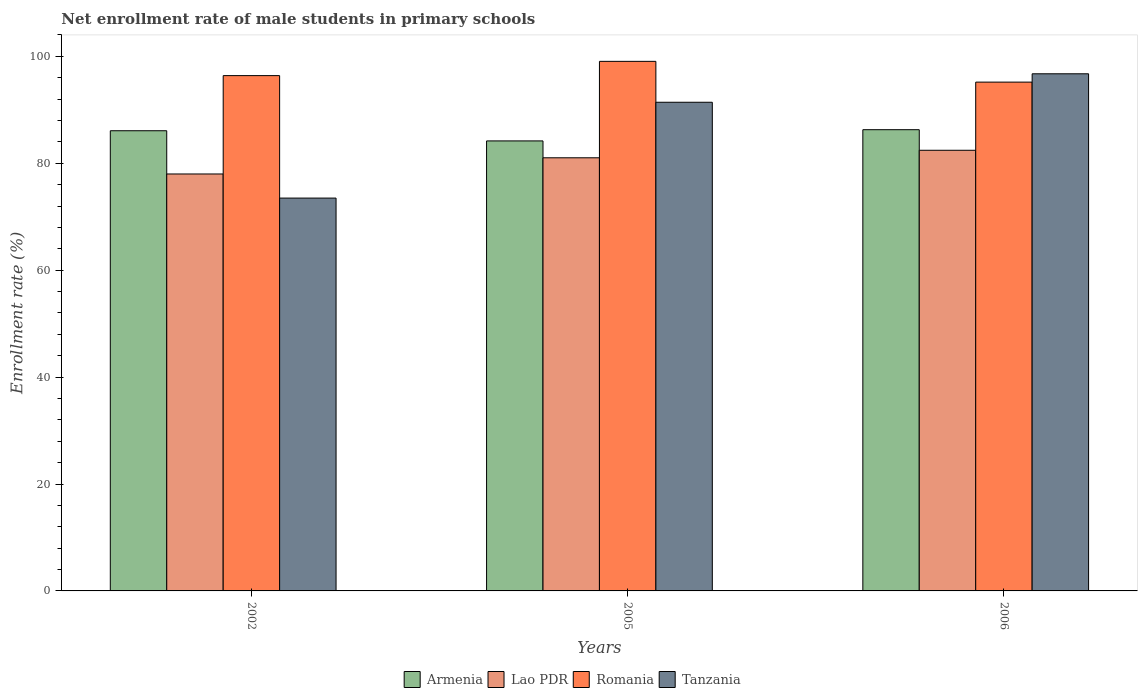How many different coloured bars are there?
Offer a very short reply. 4. How many groups of bars are there?
Your response must be concise. 3. Are the number of bars per tick equal to the number of legend labels?
Your answer should be very brief. Yes. Are the number of bars on each tick of the X-axis equal?
Provide a short and direct response. Yes. How many bars are there on the 1st tick from the left?
Keep it short and to the point. 4. How many bars are there on the 1st tick from the right?
Offer a very short reply. 4. In how many cases, is the number of bars for a given year not equal to the number of legend labels?
Make the answer very short. 0. What is the net enrollment rate of male students in primary schools in Tanzania in 2006?
Your response must be concise. 96.73. Across all years, what is the maximum net enrollment rate of male students in primary schools in Romania?
Give a very brief answer. 99.06. Across all years, what is the minimum net enrollment rate of male students in primary schools in Tanzania?
Provide a short and direct response. 73.48. In which year was the net enrollment rate of male students in primary schools in Tanzania maximum?
Offer a very short reply. 2006. What is the total net enrollment rate of male students in primary schools in Lao PDR in the graph?
Provide a succinct answer. 241.44. What is the difference between the net enrollment rate of male students in primary schools in Armenia in 2002 and that in 2006?
Keep it short and to the point. -0.19. What is the difference between the net enrollment rate of male students in primary schools in Armenia in 2006 and the net enrollment rate of male students in primary schools in Tanzania in 2002?
Keep it short and to the point. 12.79. What is the average net enrollment rate of male students in primary schools in Tanzania per year?
Your answer should be compact. 87.21. In the year 2005, what is the difference between the net enrollment rate of male students in primary schools in Lao PDR and net enrollment rate of male students in primary schools in Tanzania?
Keep it short and to the point. -10.39. In how many years, is the net enrollment rate of male students in primary schools in Tanzania greater than 52 %?
Your answer should be compact. 3. What is the ratio of the net enrollment rate of male students in primary schools in Armenia in 2005 to that in 2006?
Keep it short and to the point. 0.98. Is the difference between the net enrollment rate of male students in primary schools in Lao PDR in 2002 and 2006 greater than the difference between the net enrollment rate of male students in primary schools in Tanzania in 2002 and 2006?
Provide a short and direct response. Yes. What is the difference between the highest and the second highest net enrollment rate of male students in primary schools in Tanzania?
Provide a short and direct response. 5.32. What is the difference between the highest and the lowest net enrollment rate of male students in primary schools in Lao PDR?
Your answer should be very brief. 4.44. Is it the case that in every year, the sum of the net enrollment rate of male students in primary schools in Lao PDR and net enrollment rate of male students in primary schools in Tanzania is greater than the sum of net enrollment rate of male students in primary schools in Armenia and net enrollment rate of male students in primary schools in Romania?
Your answer should be very brief. No. What does the 4th bar from the left in 2006 represents?
Offer a very short reply. Tanzania. What does the 3rd bar from the right in 2006 represents?
Give a very brief answer. Lao PDR. Is it the case that in every year, the sum of the net enrollment rate of male students in primary schools in Lao PDR and net enrollment rate of male students in primary schools in Romania is greater than the net enrollment rate of male students in primary schools in Tanzania?
Your answer should be very brief. Yes. How many legend labels are there?
Give a very brief answer. 4. What is the title of the graph?
Your answer should be very brief. Net enrollment rate of male students in primary schools. What is the label or title of the X-axis?
Keep it short and to the point. Years. What is the label or title of the Y-axis?
Your response must be concise. Enrollment rate (%). What is the Enrollment rate (%) of Armenia in 2002?
Provide a short and direct response. 86.08. What is the Enrollment rate (%) of Lao PDR in 2002?
Give a very brief answer. 77.99. What is the Enrollment rate (%) in Romania in 2002?
Provide a short and direct response. 96.39. What is the Enrollment rate (%) in Tanzania in 2002?
Offer a terse response. 73.48. What is the Enrollment rate (%) in Armenia in 2005?
Ensure brevity in your answer.  84.18. What is the Enrollment rate (%) of Lao PDR in 2005?
Offer a terse response. 81.02. What is the Enrollment rate (%) in Romania in 2005?
Provide a short and direct response. 99.06. What is the Enrollment rate (%) in Tanzania in 2005?
Ensure brevity in your answer.  91.41. What is the Enrollment rate (%) of Armenia in 2006?
Keep it short and to the point. 86.27. What is the Enrollment rate (%) in Lao PDR in 2006?
Provide a short and direct response. 82.43. What is the Enrollment rate (%) in Romania in 2006?
Offer a very short reply. 95.18. What is the Enrollment rate (%) of Tanzania in 2006?
Give a very brief answer. 96.73. Across all years, what is the maximum Enrollment rate (%) in Armenia?
Give a very brief answer. 86.27. Across all years, what is the maximum Enrollment rate (%) of Lao PDR?
Your answer should be very brief. 82.43. Across all years, what is the maximum Enrollment rate (%) in Romania?
Keep it short and to the point. 99.06. Across all years, what is the maximum Enrollment rate (%) of Tanzania?
Make the answer very short. 96.73. Across all years, what is the minimum Enrollment rate (%) of Armenia?
Provide a short and direct response. 84.18. Across all years, what is the minimum Enrollment rate (%) of Lao PDR?
Provide a succinct answer. 77.99. Across all years, what is the minimum Enrollment rate (%) in Romania?
Provide a succinct answer. 95.18. Across all years, what is the minimum Enrollment rate (%) in Tanzania?
Offer a very short reply. 73.48. What is the total Enrollment rate (%) of Armenia in the graph?
Make the answer very short. 256.53. What is the total Enrollment rate (%) of Lao PDR in the graph?
Your response must be concise. 241.44. What is the total Enrollment rate (%) of Romania in the graph?
Your answer should be compact. 290.63. What is the total Enrollment rate (%) of Tanzania in the graph?
Your answer should be very brief. 261.62. What is the difference between the Enrollment rate (%) in Armenia in 2002 and that in 2005?
Provide a short and direct response. 1.9. What is the difference between the Enrollment rate (%) of Lao PDR in 2002 and that in 2005?
Make the answer very short. -3.03. What is the difference between the Enrollment rate (%) in Romania in 2002 and that in 2005?
Keep it short and to the point. -2.67. What is the difference between the Enrollment rate (%) in Tanzania in 2002 and that in 2005?
Keep it short and to the point. -17.93. What is the difference between the Enrollment rate (%) in Armenia in 2002 and that in 2006?
Your answer should be compact. -0.19. What is the difference between the Enrollment rate (%) of Lao PDR in 2002 and that in 2006?
Your answer should be compact. -4.44. What is the difference between the Enrollment rate (%) of Romania in 2002 and that in 2006?
Give a very brief answer. 1.22. What is the difference between the Enrollment rate (%) in Tanzania in 2002 and that in 2006?
Ensure brevity in your answer.  -23.25. What is the difference between the Enrollment rate (%) of Armenia in 2005 and that in 2006?
Offer a very short reply. -2.1. What is the difference between the Enrollment rate (%) in Lao PDR in 2005 and that in 2006?
Give a very brief answer. -1.41. What is the difference between the Enrollment rate (%) of Romania in 2005 and that in 2006?
Offer a terse response. 3.88. What is the difference between the Enrollment rate (%) of Tanzania in 2005 and that in 2006?
Give a very brief answer. -5.32. What is the difference between the Enrollment rate (%) of Armenia in 2002 and the Enrollment rate (%) of Lao PDR in 2005?
Keep it short and to the point. 5.06. What is the difference between the Enrollment rate (%) in Armenia in 2002 and the Enrollment rate (%) in Romania in 2005?
Ensure brevity in your answer.  -12.98. What is the difference between the Enrollment rate (%) in Armenia in 2002 and the Enrollment rate (%) in Tanzania in 2005?
Offer a terse response. -5.33. What is the difference between the Enrollment rate (%) in Lao PDR in 2002 and the Enrollment rate (%) in Romania in 2005?
Your answer should be very brief. -21.07. What is the difference between the Enrollment rate (%) in Lao PDR in 2002 and the Enrollment rate (%) in Tanzania in 2005?
Your response must be concise. -13.42. What is the difference between the Enrollment rate (%) in Romania in 2002 and the Enrollment rate (%) in Tanzania in 2005?
Give a very brief answer. 4.98. What is the difference between the Enrollment rate (%) in Armenia in 2002 and the Enrollment rate (%) in Lao PDR in 2006?
Keep it short and to the point. 3.65. What is the difference between the Enrollment rate (%) of Armenia in 2002 and the Enrollment rate (%) of Romania in 2006?
Provide a succinct answer. -9.1. What is the difference between the Enrollment rate (%) of Armenia in 2002 and the Enrollment rate (%) of Tanzania in 2006?
Your response must be concise. -10.65. What is the difference between the Enrollment rate (%) in Lao PDR in 2002 and the Enrollment rate (%) in Romania in 2006?
Offer a very short reply. -17.18. What is the difference between the Enrollment rate (%) in Lao PDR in 2002 and the Enrollment rate (%) in Tanzania in 2006?
Give a very brief answer. -18.74. What is the difference between the Enrollment rate (%) in Romania in 2002 and the Enrollment rate (%) in Tanzania in 2006?
Keep it short and to the point. -0.34. What is the difference between the Enrollment rate (%) of Armenia in 2005 and the Enrollment rate (%) of Lao PDR in 2006?
Offer a terse response. 1.75. What is the difference between the Enrollment rate (%) in Armenia in 2005 and the Enrollment rate (%) in Romania in 2006?
Your answer should be compact. -11. What is the difference between the Enrollment rate (%) in Armenia in 2005 and the Enrollment rate (%) in Tanzania in 2006?
Ensure brevity in your answer.  -12.56. What is the difference between the Enrollment rate (%) in Lao PDR in 2005 and the Enrollment rate (%) in Romania in 2006?
Give a very brief answer. -14.16. What is the difference between the Enrollment rate (%) in Lao PDR in 2005 and the Enrollment rate (%) in Tanzania in 2006?
Provide a short and direct response. -15.71. What is the difference between the Enrollment rate (%) of Romania in 2005 and the Enrollment rate (%) of Tanzania in 2006?
Offer a very short reply. 2.33. What is the average Enrollment rate (%) in Armenia per year?
Make the answer very short. 85.51. What is the average Enrollment rate (%) in Lao PDR per year?
Offer a terse response. 80.48. What is the average Enrollment rate (%) in Romania per year?
Provide a short and direct response. 96.88. What is the average Enrollment rate (%) in Tanzania per year?
Offer a very short reply. 87.21. In the year 2002, what is the difference between the Enrollment rate (%) in Armenia and Enrollment rate (%) in Lao PDR?
Ensure brevity in your answer.  8.09. In the year 2002, what is the difference between the Enrollment rate (%) in Armenia and Enrollment rate (%) in Romania?
Your answer should be very brief. -10.31. In the year 2002, what is the difference between the Enrollment rate (%) of Armenia and Enrollment rate (%) of Tanzania?
Offer a terse response. 12.6. In the year 2002, what is the difference between the Enrollment rate (%) of Lao PDR and Enrollment rate (%) of Romania?
Your answer should be very brief. -18.4. In the year 2002, what is the difference between the Enrollment rate (%) of Lao PDR and Enrollment rate (%) of Tanzania?
Provide a short and direct response. 4.51. In the year 2002, what is the difference between the Enrollment rate (%) of Romania and Enrollment rate (%) of Tanzania?
Your answer should be compact. 22.91. In the year 2005, what is the difference between the Enrollment rate (%) in Armenia and Enrollment rate (%) in Lao PDR?
Offer a very short reply. 3.16. In the year 2005, what is the difference between the Enrollment rate (%) in Armenia and Enrollment rate (%) in Romania?
Give a very brief answer. -14.88. In the year 2005, what is the difference between the Enrollment rate (%) of Armenia and Enrollment rate (%) of Tanzania?
Keep it short and to the point. -7.23. In the year 2005, what is the difference between the Enrollment rate (%) of Lao PDR and Enrollment rate (%) of Romania?
Make the answer very short. -18.04. In the year 2005, what is the difference between the Enrollment rate (%) of Lao PDR and Enrollment rate (%) of Tanzania?
Ensure brevity in your answer.  -10.39. In the year 2005, what is the difference between the Enrollment rate (%) of Romania and Enrollment rate (%) of Tanzania?
Give a very brief answer. 7.65. In the year 2006, what is the difference between the Enrollment rate (%) of Armenia and Enrollment rate (%) of Lao PDR?
Provide a short and direct response. 3.85. In the year 2006, what is the difference between the Enrollment rate (%) in Armenia and Enrollment rate (%) in Romania?
Provide a short and direct response. -8.9. In the year 2006, what is the difference between the Enrollment rate (%) in Armenia and Enrollment rate (%) in Tanzania?
Provide a succinct answer. -10.46. In the year 2006, what is the difference between the Enrollment rate (%) of Lao PDR and Enrollment rate (%) of Romania?
Provide a succinct answer. -12.75. In the year 2006, what is the difference between the Enrollment rate (%) in Lao PDR and Enrollment rate (%) in Tanzania?
Ensure brevity in your answer.  -14.3. In the year 2006, what is the difference between the Enrollment rate (%) of Romania and Enrollment rate (%) of Tanzania?
Offer a terse response. -1.56. What is the ratio of the Enrollment rate (%) of Armenia in 2002 to that in 2005?
Offer a very short reply. 1.02. What is the ratio of the Enrollment rate (%) in Lao PDR in 2002 to that in 2005?
Offer a very short reply. 0.96. What is the ratio of the Enrollment rate (%) in Romania in 2002 to that in 2005?
Your response must be concise. 0.97. What is the ratio of the Enrollment rate (%) of Tanzania in 2002 to that in 2005?
Ensure brevity in your answer.  0.8. What is the ratio of the Enrollment rate (%) of Lao PDR in 2002 to that in 2006?
Offer a terse response. 0.95. What is the ratio of the Enrollment rate (%) in Romania in 2002 to that in 2006?
Keep it short and to the point. 1.01. What is the ratio of the Enrollment rate (%) of Tanzania in 2002 to that in 2006?
Offer a very short reply. 0.76. What is the ratio of the Enrollment rate (%) in Armenia in 2005 to that in 2006?
Your response must be concise. 0.98. What is the ratio of the Enrollment rate (%) in Lao PDR in 2005 to that in 2006?
Offer a terse response. 0.98. What is the ratio of the Enrollment rate (%) of Romania in 2005 to that in 2006?
Your answer should be compact. 1.04. What is the ratio of the Enrollment rate (%) in Tanzania in 2005 to that in 2006?
Your answer should be very brief. 0.94. What is the difference between the highest and the second highest Enrollment rate (%) of Armenia?
Give a very brief answer. 0.19. What is the difference between the highest and the second highest Enrollment rate (%) in Lao PDR?
Provide a succinct answer. 1.41. What is the difference between the highest and the second highest Enrollment rate (%) of Romania?
Your answer should be very brief. 2.67. What is the difference between the highest and the second highest Enrollment rate (%) in Tanzania?
Provide a short and direct response. 5.32. What is the difference between the highest and the lowest Enrollment rate (%) of Armenia?
Make the answer very short. 2.1. What is the difference between the highest and the lowest Enrollment rate (%) in Lao PDR?
Provide a succinct answer. 4.44. What is the difference between the highest and the lowest Enrollment rate (%) in Romania?
Your answer should be very brief. 3.88. What is the difference between the highest and the lowest Enrollment rate (%) of Tanzania?
Ensure brevity in your answer.  23.25. 